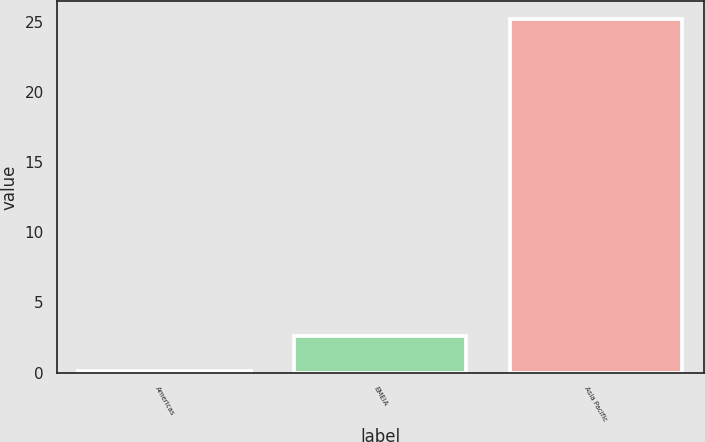Convert chart. <chart><loc_0><loc_0><loc_500><loc_500><bar_chart><fcel>Americas<fcel>EMEIA<fcel>Asia Pacific<nl><fcel>0.1<fcel>2.61<fcel>25.2<nl></chart> 